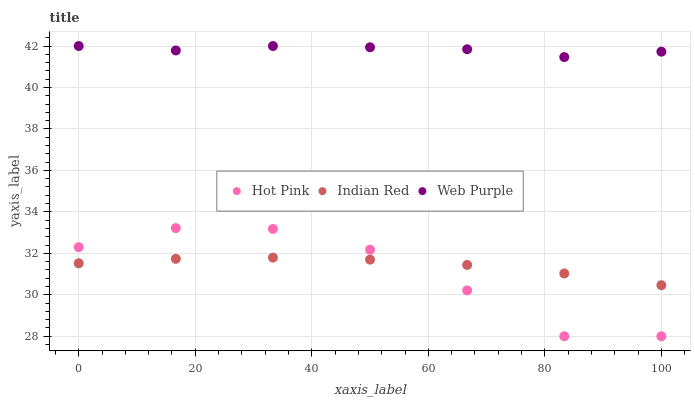Does Hot Pink have the minimum area under the curve?
Answer yes or no. Yes. Does Web Purple have the maximum area under the curve?
Answer yes or no. Yes. Does Indian Red have the minimum area under the curve?
Answer yes or no. No. Does Indian Red have the maximum area under the curve?
Answer yes or no. No. Is Indian Red the smoothest?
Answer yes or no. Yes. Is Hot Pink the roughest?
Answer yes or no. Yes. Is Hot Pink the smoothest?
Answer yes or no. No. Is Indian Red the roughest?
Answer yes or no. No. Does Hot Pink have the lowest value?
Answer yes or no. Yes. Does Indian Red have the lowest value?
Answer yes or no. No. Does Web Purple have the highest value?
Answer yes or no. Yes. Does Hot Pink have the highest value?
Answer yes or no. No. Is Indian Red less than Web Purple?
Answer yes or no. Yes. Is Web Purple greater than Hot Pink?
Answer yes or no. Yes. Does Indian Red intersect Hot Pink?
Answer yes or no. Yes. Is Indian Red less than Hot Pink?
Answer yes or no. No. Is Indian Red greater than Hot Pink?
Answer yes or no. No. Does Indian Red intersect Web Purple?
Answer yes or no. No. 